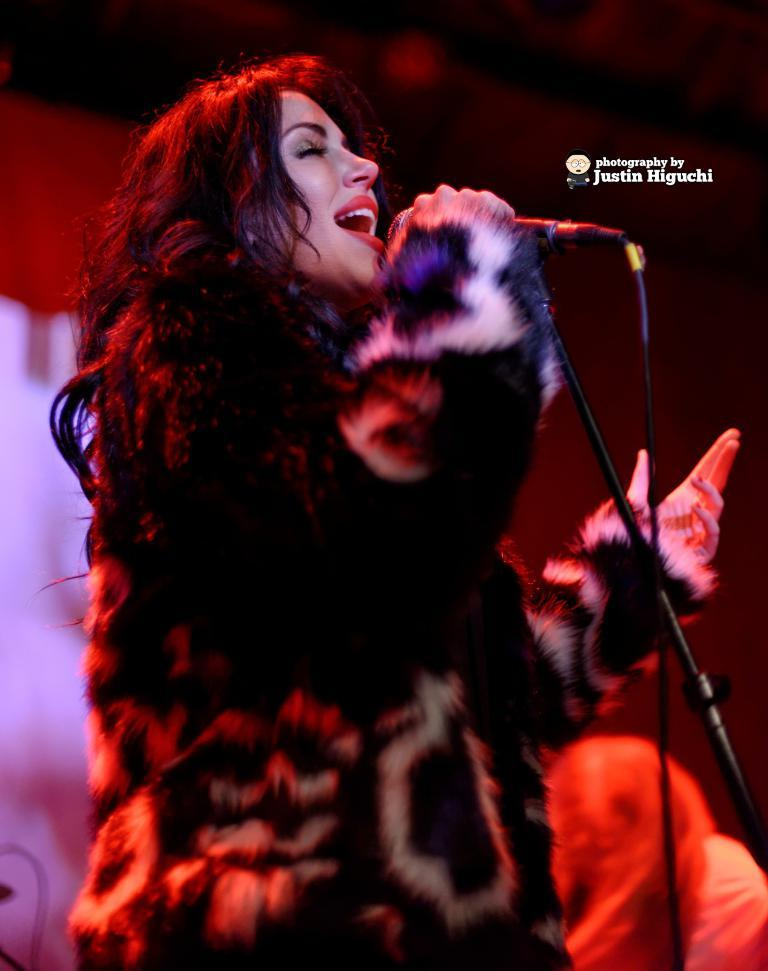What is the main subject of the image? There is a woman in the image. What is the woman holding in her hand? The woman is holding a mic in her hand. Can you describe any text that is present in the image? Yes, there is some text in the image. What can be seen in the background of the image? The background of the image contains objects. How would you describe the quality of the background in the image? The background is blurry. What type of pickle is on the scale in the image? There is no pickle or scale present in the image. What type of office furniture can be seen in the image? There is no office furniture present in the image. 